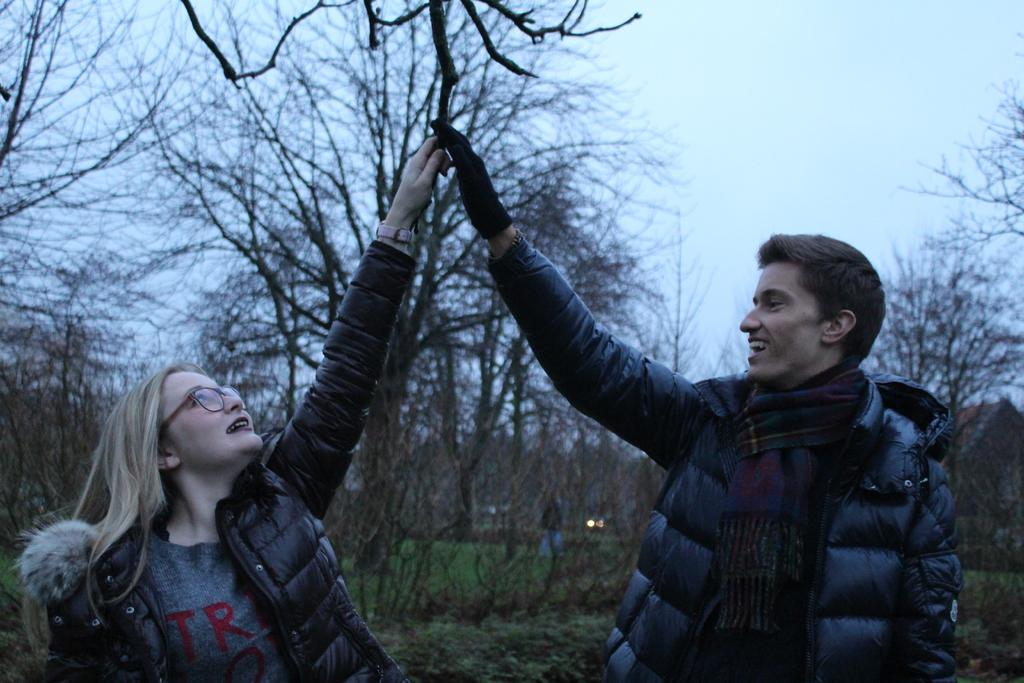How many people are present in the image? There are two persons standing in the image. What type of vegetation can be seen in the image? There are trees and grass in the image. What type of structure is visible in the image? There is a house in the image. What is visible in the background of the image? The sky is visible in the background of the image. What type of destruction can be seen in the image? There is no destruction present in the image. How quiet is the environment in the image? The image does not provide any information about the noise level or the environment's quietness. 